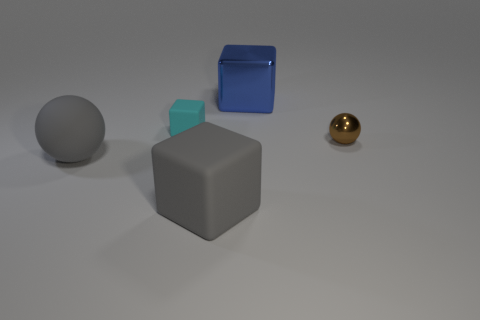Subtract all large gray cubes. How many cubes are left? 2 Subtract 1 blocks. How many blocks are left? 2 Subtract all cubes. How many objects are left? 2 Add 3 blue shiny cubes. How many objects exist? 8 Subtract all purple cubes. Subtract all green spheres. How many cubes are left? 3 Subtract all gray matte balls. Subtract all small metallic cylinders. How many objects are left? 4 Add 5 gray things. How many gray things are left? 7 Add 3 brown shiny things. How many brown shiny things exist? 4 Subtract 1 brown spheres. How many objects are left? 4 